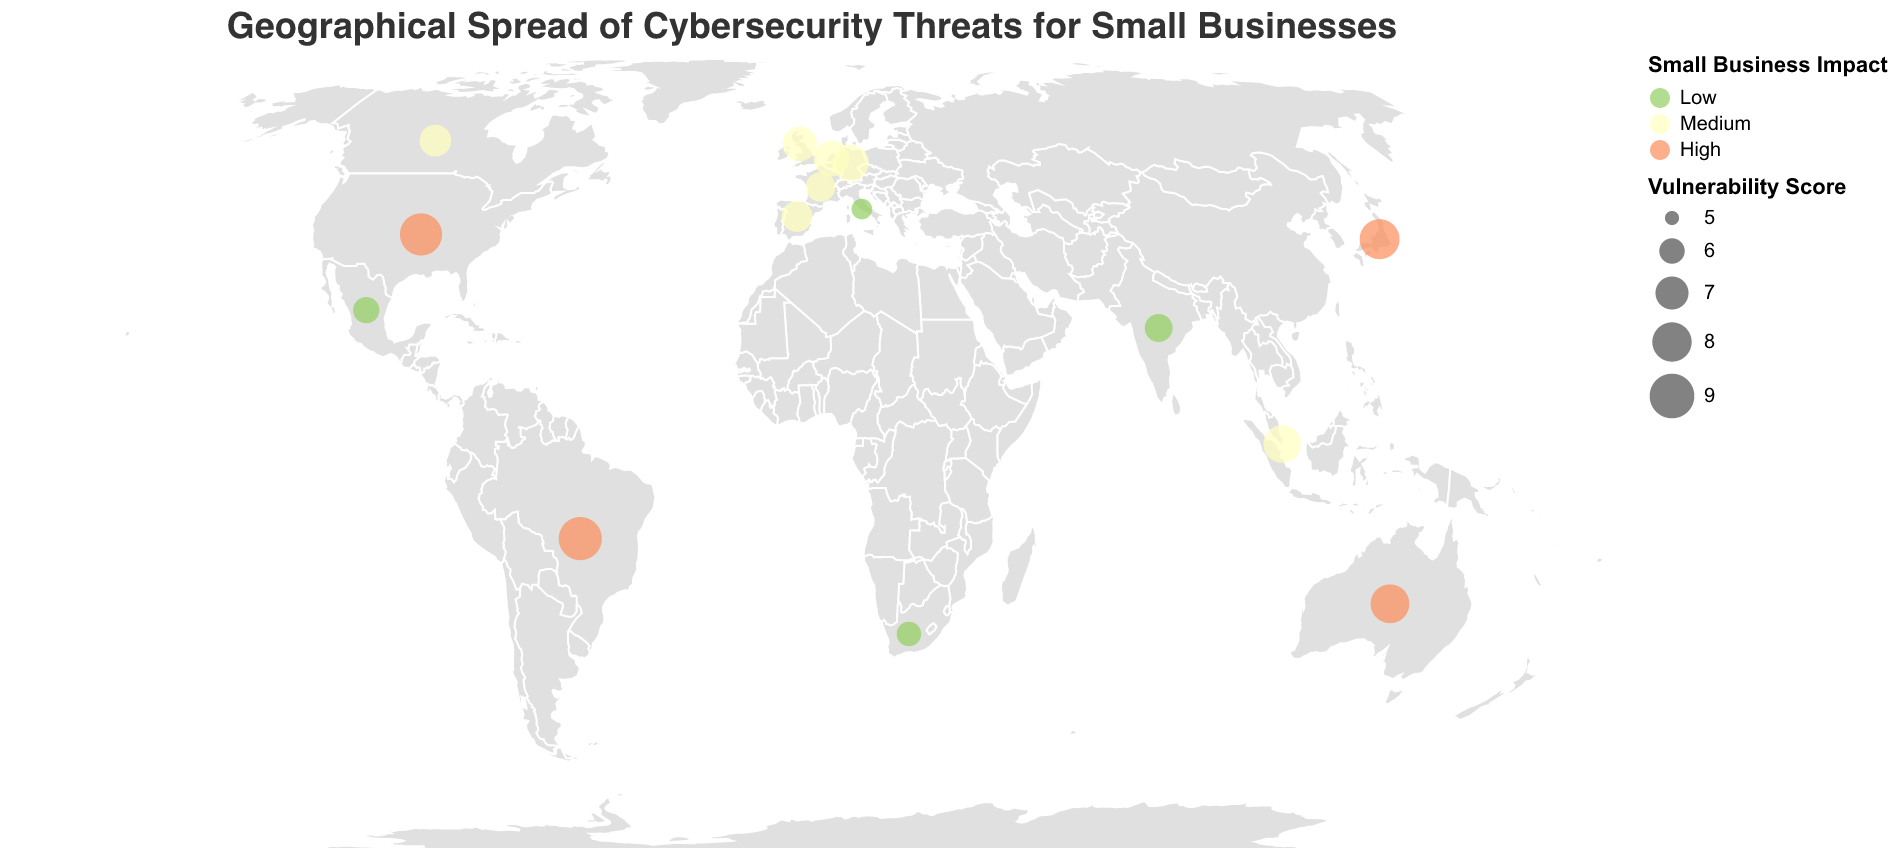1. **Question**: What is the title of this figure? **Explanation**: The title is typically found at the top of the figure, providing a concise summary of its content. In this case, the title is prominently displayed.
Answer: **Answer**: Geographical Spread of Cybersecurity Threats for Small Businesses 2. **Question**: Which country has the highest Vulnerability Score? **Explanation**: We need to look at the size of the circles on the geographic plot, which represents the Vulnerability Score. The largest circle should correspond to the highest score. Cross-reference the circle sizes with the data points.
Answer: **Answer**: Brazil 3. **Question**: How is the Small Business Impact represented in the plot? **Explanation**: The Small Business Impact is depicted using color. We need to identify how different impact levels are mapped to specific colors from the legend.
Answer: **Answer**: Low impact: green, Medium impact: yellow, High impact: red 4. **Question**: Which countries experience a 'High' impact on small businesses? **Explanation**: Countries with 'High' impacts are marked with red-colored circles. By identifying these red circles and checking the corresponding data points, we can list the countries.
Answer: **Answer**: United States, Australia, Japan, Brazil 5. **Question**: What is the average Vulnerability Score of countries with a 'Medium' impact? **Explanation**: First, identify the countries with 'Medium' impact (yellow circles). Then, sum their Vulnerability Scores and divide by the number of these countries. Countries: United Kingdom, Canada, Germany, France, Singapore, Netherlands, Spain. Calculation: (7.2 + 6.8 + 7.5 + 6.5 + 7.7 + 7.4 + 6.7) / 7 = 49.8 / 7
Answer: **Answer**: 7.11 6. **Question**: Which threat type is most prevalent across the countries shown? **Explanation**: To determine the most prevalent threat type, count the frequency of each threat type in the dataset.
Answer: **Answer**: Each threat type is unique in the dataset, so no single threat type is more prevalent 7. **Question**: Compare the Vulnerability Scores of 'Ransomware' in the United States and 'Zero-Day Exploit' in Brazil. Which one is higher? **Explanation**: Refer to the Vulnerability Scores for the respective countries and compare them directly.
Answer: **Answer**: Zero-Day Exploit in Brazil 8. **Question**: Are there more countries with 'Low' or 'High' impacts on small businesses? **Explanation**: Count the number of countries with 'Low' (green) and 'High' (red) impacts. Low impact countries: 4 (India, South Africa, Italy, Mexico) and High impact countries: 4 (United States, Australia, Japan, Brazil). Compare these counts.
Answer: **Answer**: They are equal 9. **Question**: Which country has the lowest Vulnerability Score and what threat type does it face? **Explanation**: Identify the smallest circle corresponding to the lowest Vulnerability Score. Cross-reference this with the data to find the threat type.
Answer: **Answer**: Italy, Cryptojacking 